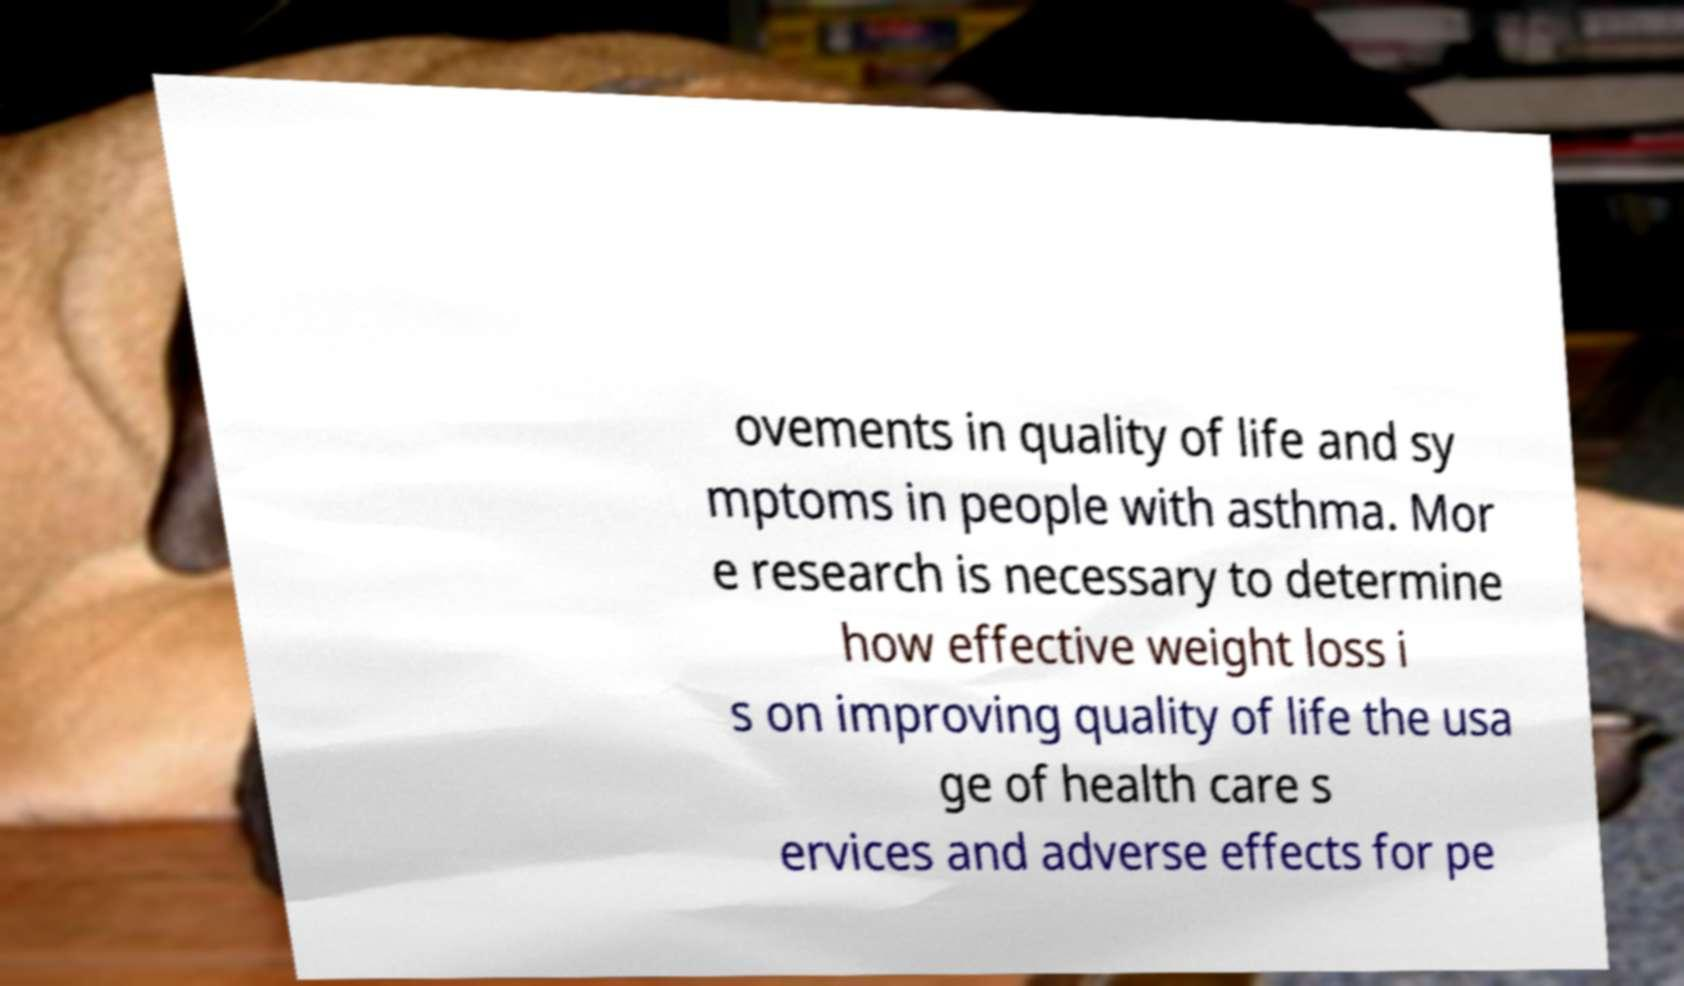For documentation purposes, I need the text within this image transcribed. Could you provide that? ovements in quality of life and sy mptoms in people with asthma. Mor e research is necessary to determine how effective weight loss i s on improving quality of life the usa ge of health care s ervices and adverse effects for pe 